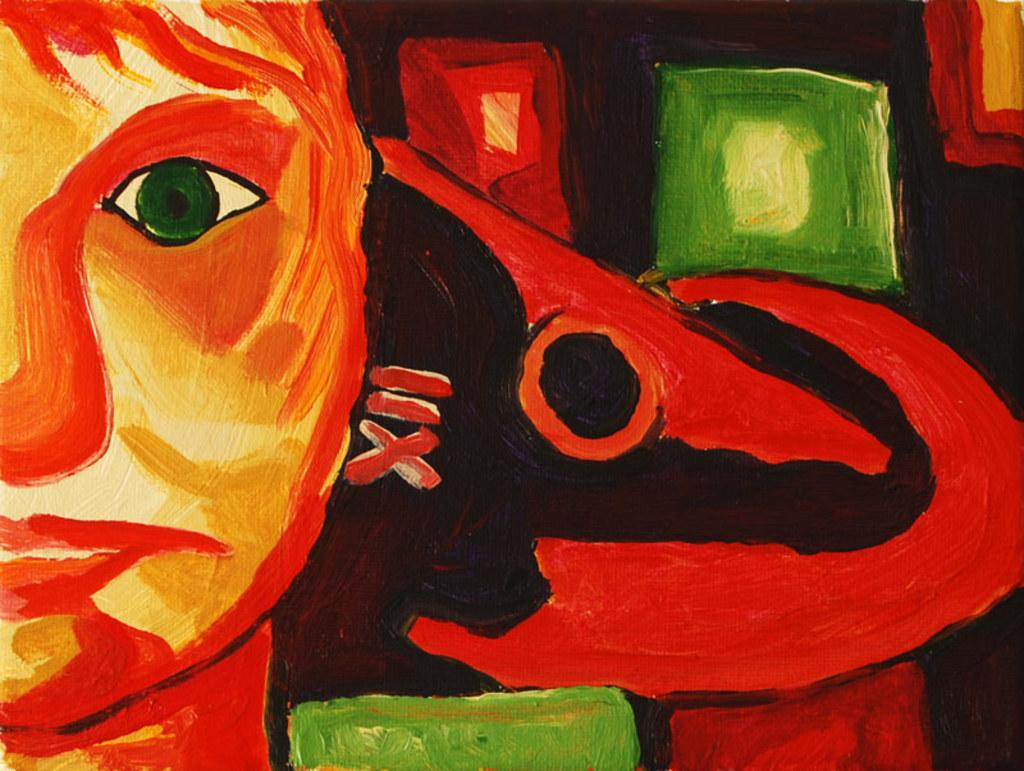What is present on the wall in the image? There is a painting of a woman's face on the wall. Can you describe the painting on the wall? The painting on the wall is of a woman's face. What type of sock is the manager wearing in the image? There is no manager or sock present in the image; it only features a wall with a painting of a woman's face. 